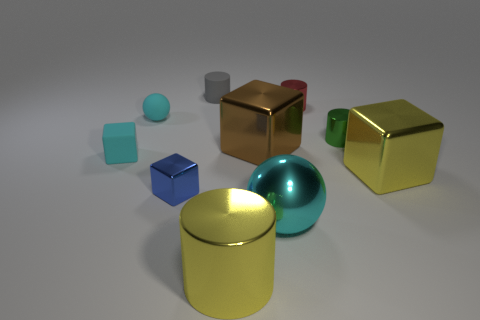Subtract 1 cubes. How many cubes are left? 3 Subtract all cubes. How many objects are left? 6 Subtract 0 red balls. How many objects are left? 10 Subtract all cyan metal spheres. Subtract all small objects. How many objects are left? 3 Add 4 small green cylinders. How many small green cylinders are left? 5 Add 1 small gray shiny spheres. How many small gray shiny spheres exist? 1 